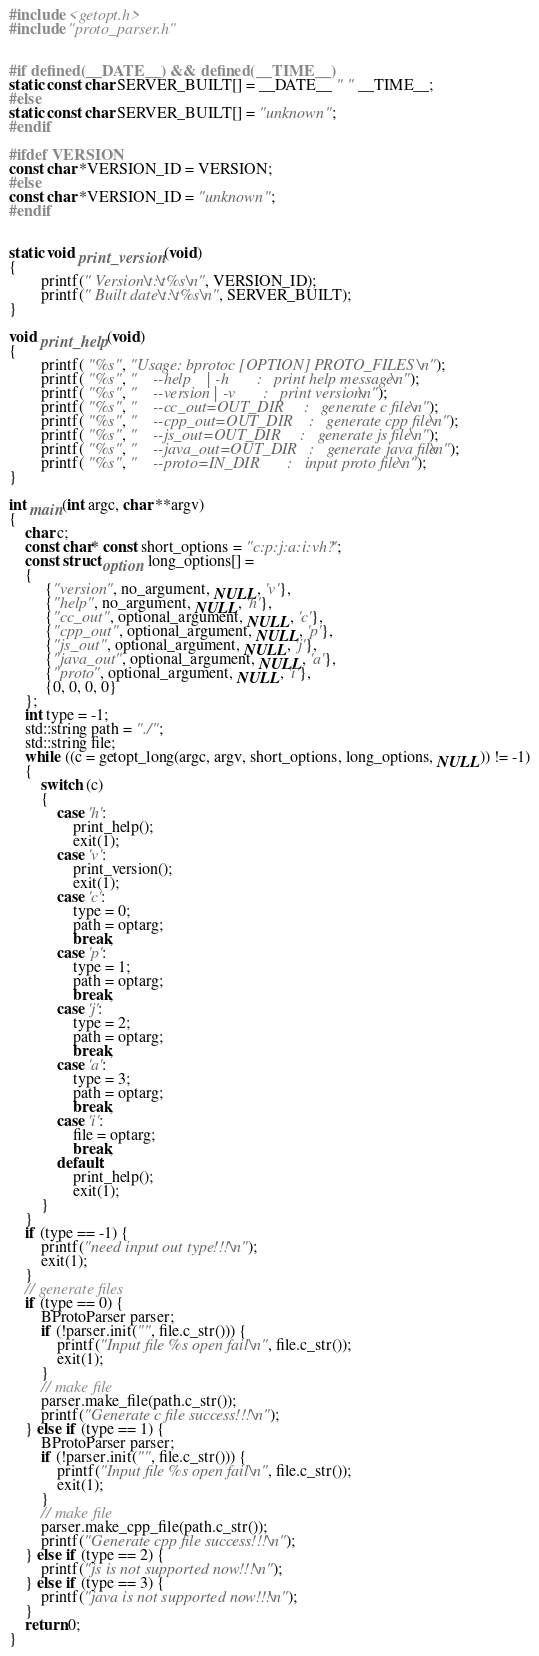<code> <loc_0><loc_0><loc_500><loc_500><_C++_>#include <getopt.h>
#include "proto_parser.h"


#if defined(__DATE__) && defined(__TIME__)
static const char SERVER_BUILT[] = __DATE__ " " __TIME__;
#else
static const char SERVER_BUILT[] = "unknown";
#endif

#ifdef VERSION
const char *VERSION_ID = VERSION;
#else
const char *VERSION_ID = "unknown";
#endif


static void print_version(void)
{                       
        printf(" Version\t:\t%s\n", VERSION_ID);
        printf(" Built date\t:\t%s\n", SERVER_BUILT);
}

void print_help(void)   
{               
        printf( "%s", "Usage: bprotoc [OPTION] PROTO_FILES \n");
        printf( "%s", "    --help    | -h       :   print help message\n");
        printf( "%s", "    --version | -v       :   print version\n");
        printf( "%s", "    --cc_out=OUT_DIR     :   generate c file\n");
        printf( "%s", "    --cpp_out=OUT_DIR    :   generate cpp file\n");
        printf( "%s", "    --js_out=OUT_DIR     :   generate js file\n");
        printf( "%s", "    --java_out=OUT_DIR   :   generate java file\n");
        printf( "%s", "    --proto=IN_DIR       :   input proto file\n");
} 

int main(int argc, char **argv)
{
    char c;
    const char* const short_options = "c:p:j:a:i:vh?"; 
    const struct option long_options[] = 
    {
         {"version", no_argument, NULL, 'v'},
         {"help", no_argument, NULL, 'h'},
         {"cc_out", optional_argument, NULL, 'c'},
         {"cpp_out", optional_argument, NULL, 'p'},
         {"js_out", optional_argument, NULL, 'j'},
         {"java_out", optional_argument, NULL, 'a'},
         {"proto", optional_argument, NULL, 'i'},
         {0, 0, 0, 0}
    };
    int type = -1;
    std::string path = "./";
    std::string file;
    while ((c = getopt_long(argc, argv, short_options, long_options, NULL)) != -1)
    {
        switch (c)
        {
            case 'h':
                print_help();
                exit(1);
            case 'v':
                print_version();
                exit(1);
            case 'c':
                type = 0;
                path = optarg;
                break;
            case 'p':
                type = 1;
                path = optarg;
                break;
            case 'j':
                type = 2;
                path = optarg;
                break;
            case 'a':
                type = 3;
                path = optarg;
                break;
            case 'i':
                file = optarg;
                break;
            default:
                print_help();
                exit(1);
        }
    }
    if (type == -1) {
        printf("need input out type!!!\n");
        exit(1);
    }
    // generate files
    if (type == 0) {
        BProtoParser parser;
        if (!parser.init("", file.c_str())) {
            printf("Input file %s open fail\n", file.c_str());
            exit(1);
        }
        // make file
        parser.make_file(path.c_str());
        printf("Generate c file success!!!\n");
    } else if (type == 1) {
        BProtoParser parser;
        if (!parser.init("", file.c_str())) {
            printf("Input file %s open fail\n", file.c_str());
            exit(1);
        }
        // make file
        parser.make_cpp_file(path.c_str());
        printf("Generate cpp file success!!!\n");
    } else if (type == 2) {
        printf("js is not supported now!!!\n");
    } else if (type == 3) {
        printf("java is not supported now!!!\n");
    }
    return 0;
}
</code> 